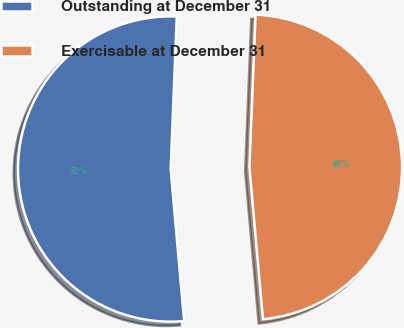Convert chart to OTSL. <chart><loc_0><loc_0><loc_500><loc_500><pie_chart><fcel>Outstanding at December 31<fcel>Exercisable at December 31<nl><fcel>52.05%<fcel>47.95%<nl></chart> 